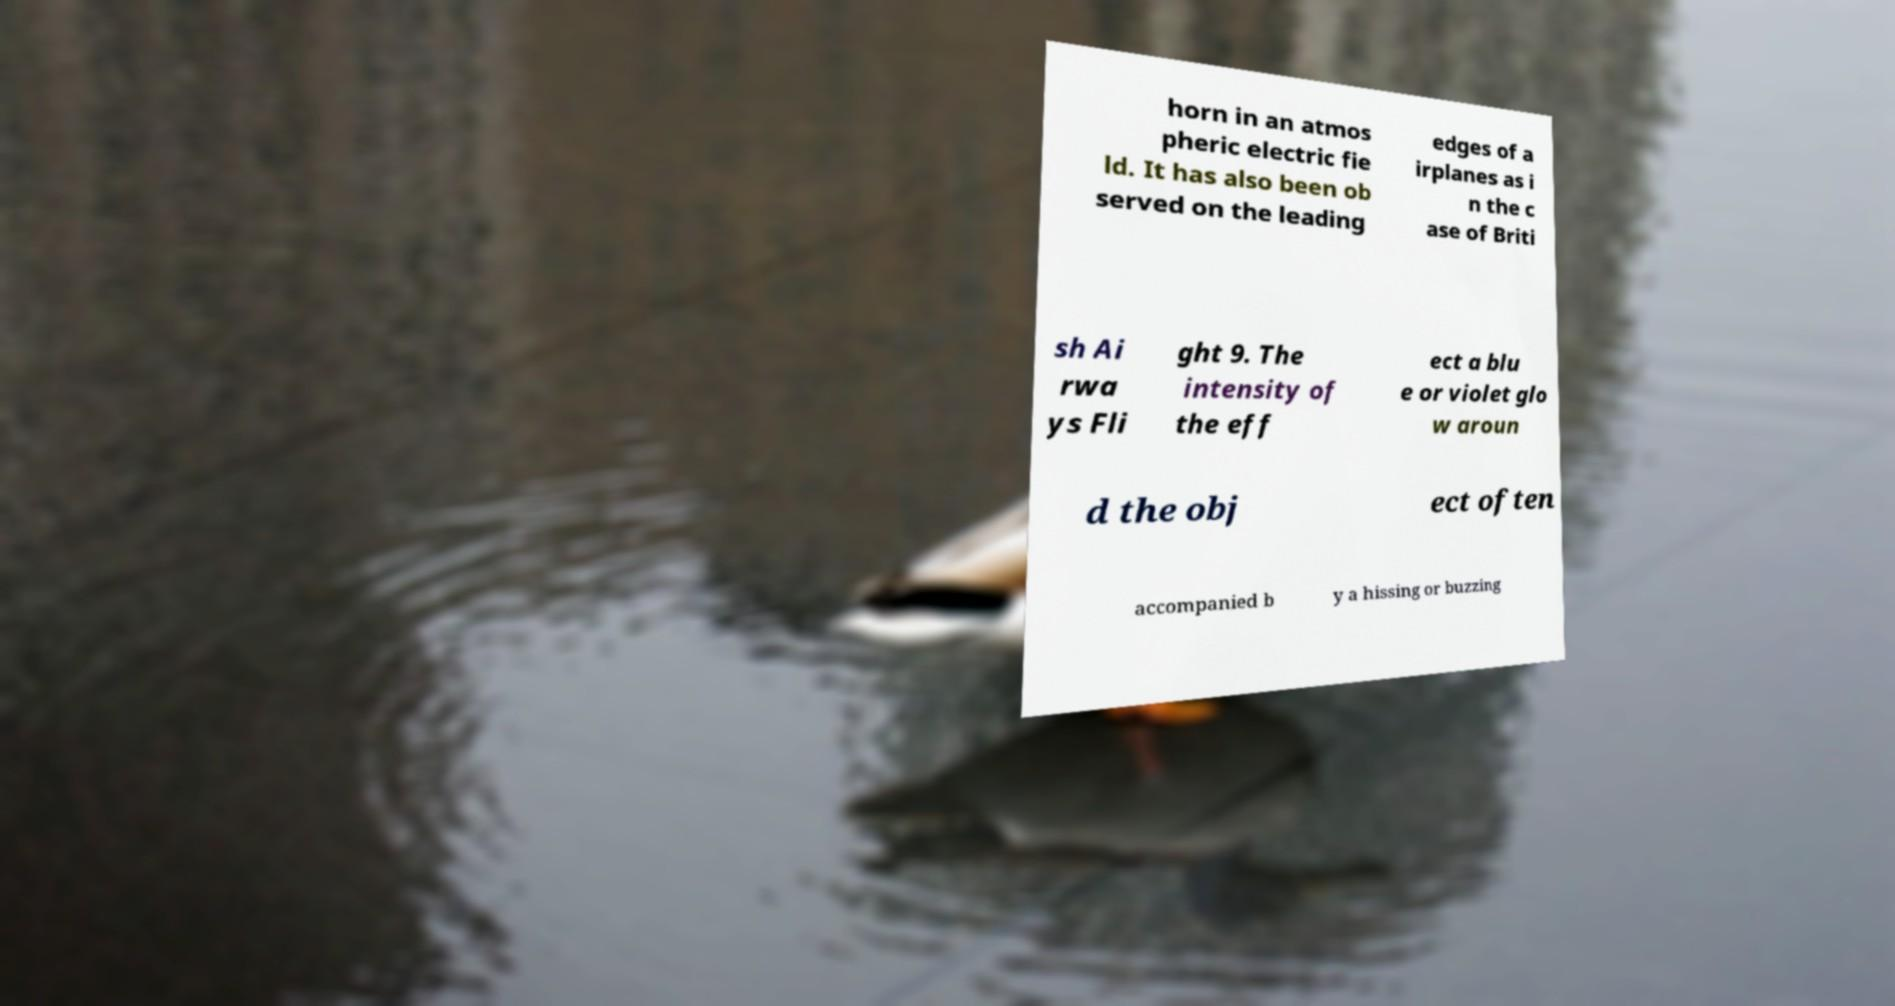Could you assist in decoding the text presented in this image and type it out clearly? horn in an atmos pheric electric fie ld. It has also been ob served on the leading edges of a irplanes as i n the c ase of Briti sh Ai rwa ys Fli ght 9. The intensity of the eff ect a blu e or violet glo w aroun d the obj ect often accompanied b y a hissing or buzzing 